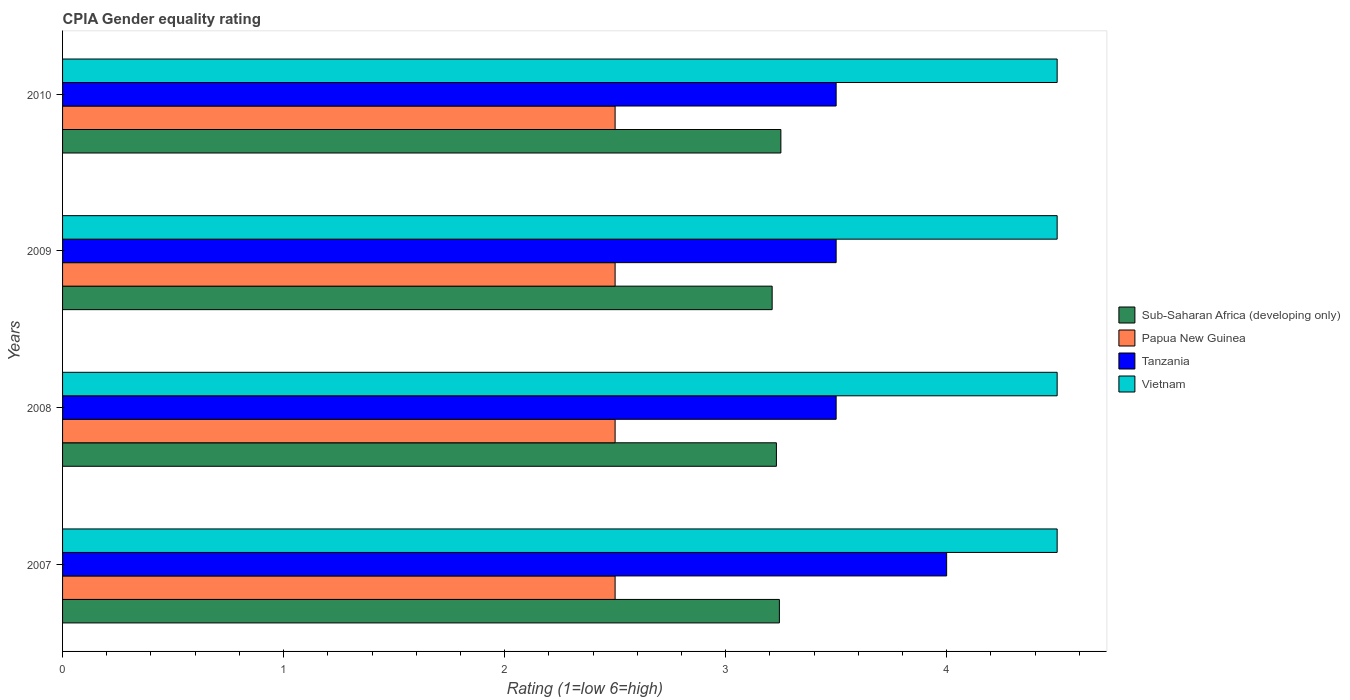How many groups of bars are there?
Offer a very short reply. 4. Are the number of bars per tick equal to the number of legend labels?
Give a very brief answer. Yes. Are the number of bars on each tick of the Y-axis equal?
Keep it short and to the point. Yes. How many bars are there on the 2nd tick from the top?
Ensure brevity in your answer.  4. Across all years, what is the maximum CPIA rating in Sub-Saharan Africa (developing only)?
Your answer should be compact. 3.25. Across all years, what is the minimum CPIA rating in Sub-Saharan Africa (developing only)?
Your answer should be compact. 3.21. In which year was the CPIA rating in Tanzania maximum?
Keep it short and to the point. 2007. What is the total CPIA rating in Sub-Saharan Africa (developing only) in the graph?
Offer a terse response. 12.93. What is the difference between the CPIA rating in Papua New Guinea in 2008 and the CPIA rating in Tanzania in 2007?
Provide a succinct answer. -1.5. What is the average CPIA rating in Tanzania per year?
Your answer should be very brief. 3.62. In the year 2008, what is the difference between the CPIA rating in Sub-Saharan Africa (developing only) and CPIA rating in Tanzania?
Ensure brevity in your answer.  -0.27. In how many years, is the CPIA rating in Vietnam greater than 4 ?
Your answer should be compact. 4. What is the ratio of the CPIA rating in Vietnam in 2007 to that in 2010?
Ensure brevity in your answer.  1. Is the CPIA rating in Sub-Saharan Africa (developing only) in 2007 less than that in 2008?
Offer a terse response. No. What is the difference between the highest and the second highest CPIA rating in Sub-Saharan Africa (developing only)?
Provide a succinct answer. 0.01. What is the difference between the highest and the lowest CPIA rating in Vietnam?
Offer a very short reply. 0. In how many years, is the CPIA rating in Papua New Guinea greater than the average CPIA rating in Papua New Guinea taken over all years?
Keep it short and to the point. 0. Is the sum of the CPIA rating in Sub-Saharan Africa (developing only) in 2007 and 2010 greater than the maximum CPIA rating in Vietnam across all years?
Make the answer very short. Yes. What does the 1st bar from the top in 2007 represents?
Offer a terse response. Vietnam. What does the 2nd bar from the bottom in 2010 represents?
Give a very brief answer. Papua New Guinea. Is it the case that in every year, the sum of the CPIA rating in Sub-Saharan Africa (developing only) and CPIA rating in Papua New Guinea is greater than the CPIA rating in Vietnam?
Give a very brief answer. Yes. Are all the bars in the graph horizontal?
Provide a short and direct response. Yes. Does the graph contain any zero values?
Offer a terse response. No. Does the graph contain grids?
Provide a succinct answer. No. Where does the legend appear in the graph?
Provide a succinct answer. Center right. How are the legend labels stacked?
Ensure brevity in your answer.  Vertical. What is the title of the graph?
Your response must be concise. CPIA Gender equality rating. What is the label or title of the Y-axis?
Give a very brief answer. Years. What is the Rating (1=low 6=high) in Sub-Saharan Africa (developing only) in 2007?
Provide a succinct answer. 3.24. What is the Rating (1=low 6=high) of Papua New Guinea in 2007?
Provide a succinct answer. 2.5. What is the Rating (1=low 6=high) of Tanzania in 2007?
Your answer should be compact. 4. What is the Rating (1=low 6=high) in Vietnam in 2007?
Your answer should be very brief. 4.5. What is the Rating (1=low 6=high) in Sub-Saharan Africa (developing only) in 2008?
Ensure brevity in your answer.  3.23. What is the Rating (1=low 6=high) of Tanzania in 2008?
Your response must be concise. 3.5. What is the Rating (1=low 6=high) in Vietnam in 2008?
Keep it short and to the point. 4.5. What is the Rating (1=low 6=high) in Sub-Saharan Africa (developing only) in 2009?
Provide a succinct answer. 3.21. What is the Rating (1=low 6=high) in Papua New Guinea in 2009?
Give a very brief answer. 2.5. What is the Rating (1=low 6=high) in Vietnam in 2009?
Your response must be concise. 4.5. What is the Rating (1=low 6=high) in Papua New Guinea in 2010?
Offer a very short reply. 2.5. What is the Rating (1=low 6=high) of Vietnam in 2010?
Make the answer very short. 4.5. Across all years, what is the maximum Rating (1=low 6=high) in Papua New Guinea?
Give a very brief answer. 2.5. Across all years, what is the maximum Rating (1=low 6=high) of Tanzania?
Provide a short and direct response. 4. Across all years, what is the maximum Rating (1=low 6=high) in Vietnam?
Provide a succinct answer. 4.5. Across all years, what is the minimum Rating (1=low 6=high) in Sub-Saharan Africa (developing only)?
Provide a short and direct response. 3.21. Across all years, what is the minimum Rating (1=low 6=high) of Papua New Guinea?
Keep it short and to the point. 2.5. What is the total Rating (1=low 6=high) of Sub-Saharan Africa (developing only) in the graph?
Provide a short and direct response. 12.93. What is the total Rating (1=low 6=high) of Papua New Guinea in the graph?
Your response must be concise. 10. What is the total Rating (1=low 6=high) of Tanzania in the graph?
Offer a very short reply. 14.5. What is the difference between the Rating (1=low 6=high) in Sub-Saharan Africa (developing only) in 2007 and that in 2008?
Provide a short and direct response. 0.01. What is the difference between the Rating (1=low 6=high) of Tanzania in 2007 and that in 2008?
Give a very brief answer. 0.5. What is the difference between the Rating (1=low 6=high) of Sub-Saharan Africa (developing only) in 2007 and that in 2009?
Ensure brevity in your answer.  0.03. What is the difference between the Rating (1=low 6=high) of Papua New Guinea in 2007 and that in 2009?
Your answer should be very brief. 0. What is the difference between the Rating (1=low 6=high) of Tanzania in 2007 and that in 2009?
Make the answer very short. 0.5. What is the difference between the Rating (1=low 6=high) in Sub-Saharan Africa (developing only) in 2007 and that in 2010?
Ensure brevity in your answer.  -0.01. What is the difference between the Rating (1=low 6=high) of Tanzania in 2007 and that in 2010?
Offer a very short reply. 0.5. What is the difference between the Rating (1=low 6=high) in Sub-Saharan Africa (developing only) in 2008 and that in 2009?
Provide a short and direct response. 0.02. What is the difference between the Rating (1=low 6=high) in Tanzania in 2008 and that in 2009?
Make the answer very short. 0. What is the difference between the Rating (1=low 6=high) in Vietnam in 2008 and that in 2009?
Offer a very short reply. 0. What is the difference between the Rating (1=low 6=high) in Sub-Saharan Africa (developing only) in 2008 and that in 2010?
Provide a short and direct response. -0.02. What is the difference between the Rating (1=low 6=high) of Papua New Guinea in 2008 and that in 2010?
Provide a succinct answer. 0. What is the difference between the Rating (1=low 6=high) of Tanzania in 2008 and that in 2010?
Your answer should be very brief. 0. What is the difference between the Rating (1=low 6=high) of Vietnam in 2008 and that in 2010?
Offer a terse response. 0. What is the difference between the Rating (1=low 6=high) of Sub-Saharan Africa (developing only) in 2009 and that in 2010?
Offer a very short reply. -0.04. What is the difference between the Rating (1=low 6=high) of Sub-Saharan Africa (developing only) in 2007 and the Rating (1=low 6=high) of Papua New Guinea in 2008?
Keep it short and to the point. 0.74. What is the difference between the Rating (1=low 6=high) of Sub-Saharan Africa (developing only) in 2007 and the Rating (1=low 6=high) of Tanzania in 2008?
Make the answer very short. -0.26. What is the difference between the Rating (1=low 6=high) of Sub-Saharan Africa (developing only) in 2007 and the Rating (1=low 6=high) of Vietnam in 2008?
Keep it short and to the point. -1.26. What is the difference between the Rating (1=low 6=high) in Papua New Guinea in 2007 and the Rating (1=low 6=high) in Vietnam in 2008?
Keep it short and to the point. -2. What is the difference between the Rating (1=low 6=high) of Tanzania in 2007 and the Rating (1=low 6=high) of Vietnam in 2008?
Offer a very short reply. -0.5. What is the difference between the Rating (1=low 6=high) of Sub-Saharan Africa (developing only) in 2007 and the Rating (1=low 6=high) of Papua New Guinea in 2009?
Ensure brevity in your answer.  0.74. What is the difference between the Rating (1=low 6=high) in Sub-Saharan Africa (developing only) in 2007 and the Rating (1=low 6=high) in Tanzania in 2009?
Your answer should be very brief. -0.26. What is the difference between the Rating (1=low 6=high) of Sub-Saharan Africa (developing only) in 2007 and the Rating (1=low 6=high) of Vietnam in 2009?
Your answer should be compact. -1.26. What is the difference between the Rating (1=low 6=high) of Papua New Guinea in 2007 and the Rating (1=low 6=high) of Tanzania in 2009?
Make the answer very short. -1. What is the difference between the Rating (1=low 6=high) of Tanzania in 2007 and the Rating (1=low 6=high) of Vietnam in 2009?
Offer a terse response. -0.5. What is the difference between the Rating (1=low 6=high) in Sub-Saharan Africa (developing only) in 2007 and the Rating (1=low 6=high) in Papua New Guinea in 2010?
Provide a short and direct response. 0.74. What is the difference between the Rating (1=low 6=high) in Sub-Saharan Africa (developing only) in 2007 and the Rating (1=low 6=high) in Tanzania in 2010?
Offer a very short reply. -0.26. What is the difference between the Rating (1=low 6=high) in Sub-Saharan Africa (developing only) in 2007 and the Rating (1=low 6=high) in Vietnam in 2010?
Ensure brevity in your answer.  -1.26. What is the difference between the Rating (1=low 6=high) in Papua New Guinea in 2007 and the Rating (1=low 6=high) in Tanzania in 2010?
Your response must be concise. -1. What is the difference between the Rating (1=low 6=high) of Sub-Saharan Africa (developing only) in 2008 and the Rating (1=low 6=high) of Papua New Guinea in 2009?
Provide a short and direct response. 0.73. What is the difference between the Rating (1=low 6=high) in Sub-Saharan Africa (developing only) in 2008 and the Rating (1=low 6=high) in Tanzania in 2009?
Ensure brevity in your answer.  -0.27. What is the difference between the Rating (1=low 6=high) in Sub-Saharan Africa (developing only) in 2008 and the Rating (1=low 6=high) in Vietnam in 2009?
Keep it short and to the point. -1.27. What is the difference between the Rating (1=low 6=high) in Sub-Saharan Africa (developing only) in 2008 and the Rating (1=low 6=high) in Papua New Guinea in 2010?
Offer a very short reply. 0.73. What is the difference between the Rating (1=low 6=high) in Sub-Saharan Africa (developing only) in 2008 and the Rating (1=low 6=high) in Tanzania in 2010?
Your answer should be compact. -0.27. What is the difference between the Rating (1=low 6=high) in Sub-Saharan Africa (developing only) in 2008 and the Rating (1=low 6=high) in Vietnam in 2010?
Ensure brevity in your answer.  -1.27. What is the difference between the Rating (1=low 6=high) in Tanzania in 2008 and the Rating (1=low 6=high) in Vietnam in 2010?
Your response must be concise. -1. What is the difference between the Rating (1=low 6=high) of Sub-Saharan Africa (developing only) in 2009 and the Rating (1=low 6=high) of Papua New Guinea in 2010?
Ensure brevity in your answer.  0.71. What is the difference between the Rating (1=low 6=high) in Sub-Saharan Africa (developing only) in 2009 and the Rating (1=low 6=high) in Tanzania in 2010?
Provide a short and direct response. -0.29. What is the difference between the Rating (1=low 6=high) of Sub-Saharan Africa (developing only) in 2009 and the Rating (1=low 6=high) of Vietnam in 2010?
Provide a succinct answer. -1.29. What is the difference between the Rating (1=low 6=high) in Papua New Guinea in 2009 and the Rating (1=low 6=high) in Tanzania in 2010?
Keep it short and to the point. -1. What is the difference between the Rating (1=low 6=high) of Papua New Guinea in 2009 and the Rating (1=low 6=high) of Vietnam in 2010?
Your answer should be compact. -2. What is the difference between the Rating (1=low 6=high) of Tanzania in 2009 and the Rating (1=low 6=high) of Vietnam in 2010?
Offer a very short reply. -1. What is the average Rating (1=low 6=high) of Sub-Saharan Africa (developing only) per year?
Give a very brief answer. 3.23. What is the average Rating (1=low 6=high) of Papua New Guinea per year?
Provide a short and direct response. 2.5. What is the average Rating (1=low 6=high) in Tanzania per year?
Make the answer very short. 3.62. What is the average Rating (1=low 6=high) in Vietnam per year?
Ensure brevity in your answer.  4.5. In the year 2007, what is the difference between the Rating (1=low 6=high) of Sub-Saharan Africa (developing only) and Rating (1=low 6=high) of Papua New Guinea?
Your response must be concise. 0.74. In the year 2007, what is the difference between the Rating (1=low 6=high) in Sub-Saharan Africa (developing only) and Rating (1=low 6=high) in Tanzania?
Your answer should be very brief. -0.76. In the year 2007, what is the difference between the Rating (1=low 6=high) in Sub-Saharan Africa (developing only) and Rating (1=low 6=high) in Vietnam?
Your response must be concise. -1.26. In the year 2007, what is the difference between the Rating (1=low 6=high) in Papua New Guinea and Rating (1=low 6=high) in Tanzania?
Provide a succinct answer. -1.5. In the year 2007, what is the difference between the Rating (1=low 6=high) in Papua New Guinea and Rating (1=low 6=high) in Vietnam?
Offer a terse response. -2. In the year 2008, what is the difference between the Rating (1=low 6=high) in Sub-Saharan Africa (developing only) and Rating (1=low 6=high) in Papua New Guinea?
Offer a very short reply. 0.73. In the year 2008, what is the difference between the Rating (1=low 6=high) of Sub-Saharan Africa (developing only) and Rating (1=low 6=high) of Tanzania?
Offer a terse response. -0.27. In the year 2008, what is the difference between the Rating (1=low 6=high) in Sub-Saharan Africa (developing only) and Rating (1=low 6=high) in Vietnam?
Make the answer very short. -1.27. In the year 2008, what is the difference between the Rating (1=low 6=high) of Papua New Guinea and Rating (1=low 6=high) of Tanzania?
Keep it short and to the point. -1. In the year 2009, what is the difference between the Rating (1=low 6=high) of Sub-Saharan Africa (developing only) and Rating (1=low 6=high) of Papua New Guinea?
Keep it short and to the point. 0.71. In the year 2009, what is the difference between the Rating (1=low 6=high) in Sub-Saharan Africa (developing only) and Rating (1=low 6=high) in Tanzania?
Your answer should be very brief. -0.29. In the year 2009, what is the difference between the Rating (1=low 6=high) of Sub-Saharan Africa (developing only) and Rating (1=low 6=high) of Vietnam?
Give a very brief answer. -1.29. In the year 2009, what is the difference between the Rating (1=low 6=high) in Papua New Guinea and Rating (1=low 6=high) in Tanzania?
Your answer should be very brief. -1. In the year 2009, what is the difference between the Rating (1=low 6=high) of Tanzania and Rating (1=low 6=high) of Vietnam?
Your answer should be compact. -1. In the year 2010, what is the difference between the Rating (1=low 6=high) of Sub-Saharan Africa (developing only) and Rating (1=low 6=high) of Papua New Guinea?
Provide a short and direct response. 0.75. In the year 2010, what is the difference between the Rating (1=low 6=high) of Sub-Saharan Africa (developing only) and Rating (1=low 6=high) of Vietnam?
Your response must be concise. -1.25. In the year 2010, what is the difference between the Rating (1=low 6=high) of Tanzania and Rating (1=low 6=high) of Vietnam?
Your answer should be very brief. -1. What is the ratio of the Rating (1=low 6=high) in Sub-Saharan Africa (developing only) in 2007 to that in 2008?
Your answer should be very brief. 1. What is the ratio of the Rating (1=low 6=high) in Papua New Guinea in 2007 to that in 2008?
Your answer should be compact. 1. What is the ratio of the Rating (1=low 6=high) in Tanzania in 2007 to that in 2008?
Give a very brief answer. 1.14. What is the ratio of the Rating (1=low 6=high) in Vietnam in 2007 to that in 2008?
Keep it short and to the point. 1. What is the ratio of the Rating (1=low 6=high) of Sub-Saharan Africa (developing only) in 2007 to that in 2009?
Your response must be concise. 1.01. What is the ratio of the Rating (1=low 6=high) of Vietnam in 2007 to that in 2009?
Offer a very short reply. 1. What is the ratio of the Rating (1=low 6=high) of Sub-Saharan Africa (developing only) in 2007 to that in 2010?
Keep it short and to the point. 1. What is the ratio of the Rating (1=low 6=high) of Tanzania in 2007 to that in 2010?
Offer a very short reply. 1.14. What is the ratio of the Rating (1=low 6=high) of Vietnam in 2007 to that in 2010?
Provide a succinct answer. 1. What is the ratio of the Rating (1=low 6=high) of Papua New Guinea in 2008 to that in 2009?
Offer a terse response. 1. What is the ratio of the Rating (1=low 6=high) of Tanzania in 2008 to that in 2009?
Your answer should be very brief. 1. What is the ratio of the Rating (1=low 6=high) in Vietnam in 2008 to that in 2009?
Your response must be concise. 1. What is the ratio of the Rating (1=low 6=high) of Sub-Saharan Africa (developing only) in 2008 to that in 2010?
Your answer should be very brief. 0.99. What is the ratio of the Rating (1=low 6=high) in Tanzania in 2008 to that in 2010?
Offer a terse response. 1. What is the ratio of the Rating (1=low 6=high) in Sub-Saharan Africa (developing only) in 2009 to that in 2010?
Your response must be concise. 0.99. What is the difference between the highest and the second highest Rating (1=low 6=high) in Sub-Saharan Africa (developing only)?
Provide a succinct answer. 0.01. What is the difference between the highest and the second highest Rating (1=low 6=high) in Papua New Guinea?
Offer a very short reply. 0. What is the difference between the highest and the second highest Rating (1=low 6=high) of Tanzania?
Offer a terse response. 0.5. What is the difference between the highest and the second highest Rating (1=low 6=high) of Vietnam?
Your response must be concise. 0. What is the difference between the highest and the lowest Rating (1=low 6=high) of Sub-Saharan Africa (developing only)?
Provide a short and direct response. 0.04. 